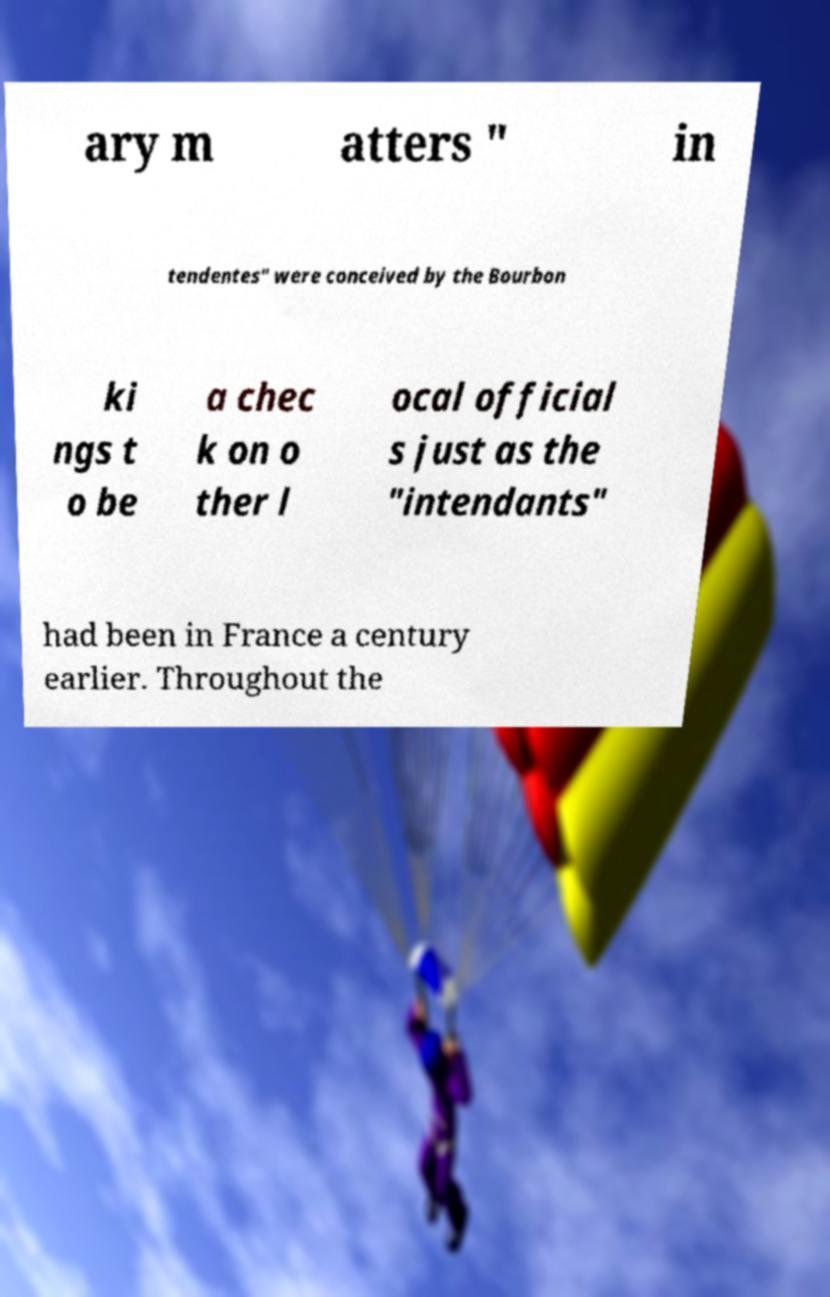Can you accurately transcribe the text from the provided image for me? ary m atters " in tendentes" were conceived by the Bourbon ki ngs t o be a chec k on o ther l ocal official s just as the "intendants" had been in France a century earlier. Throughout the 